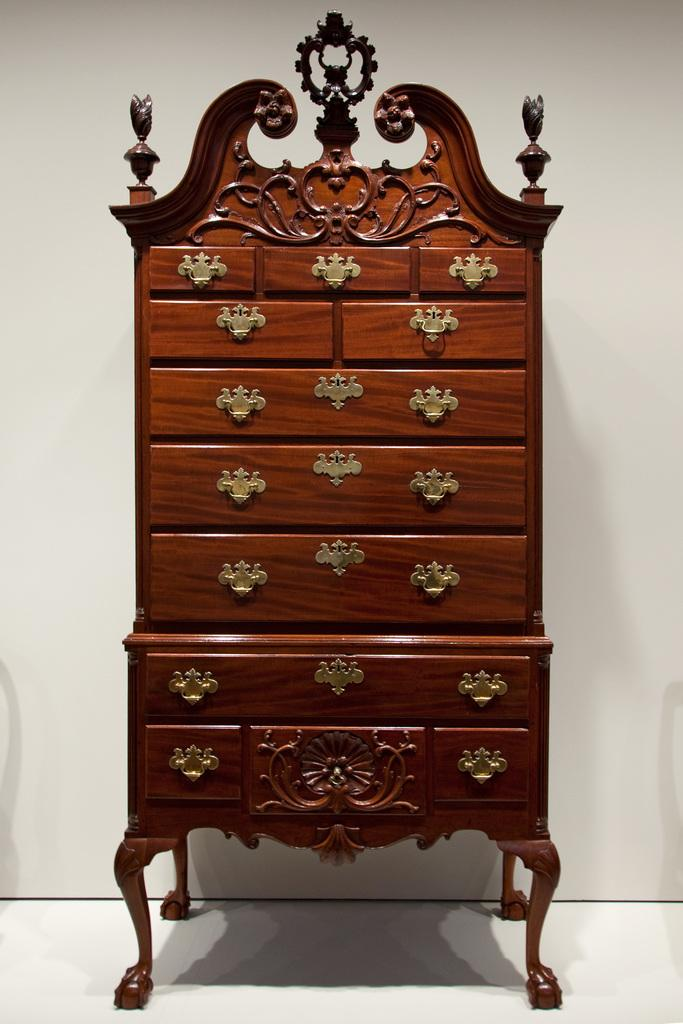What type of furniture is present in the image? There is a wooden wardrobe in the image. How is the wardrobe designed? The wardrobe is carved in a different shape. How many spiders are crawling on the wardrobe in the image? There are no spiders present in the image; it only features a wooden wardrobe. Can you tell me the name of the girl standing next to the wardrobe in the image? There is no girl present in the image; it only features a wooden wardrobe. 